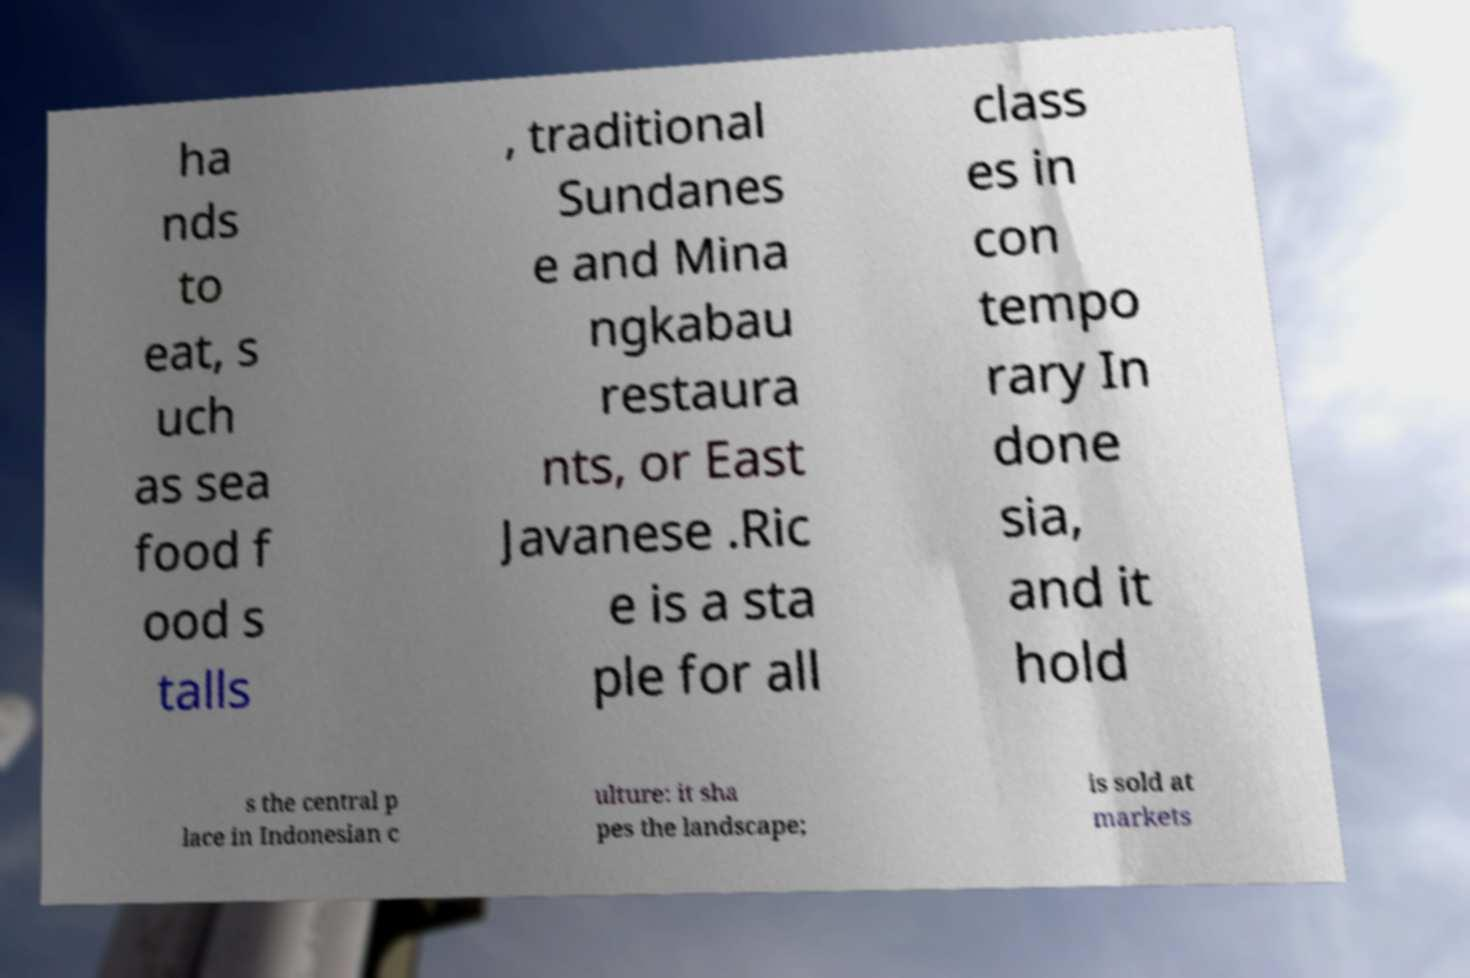Could you extract and type out the text from this image? ha nds to eat, s uch as sea food f ood s talls , traditional Sundanes e and Mina ngkabau restaura nts, or East Javanese .Ric e is a sta ple for all class es in con tempo rary In done sia, and it hold s the central p lace in Indonesian c ulture: it sha pes the landscape; is sold at markets 